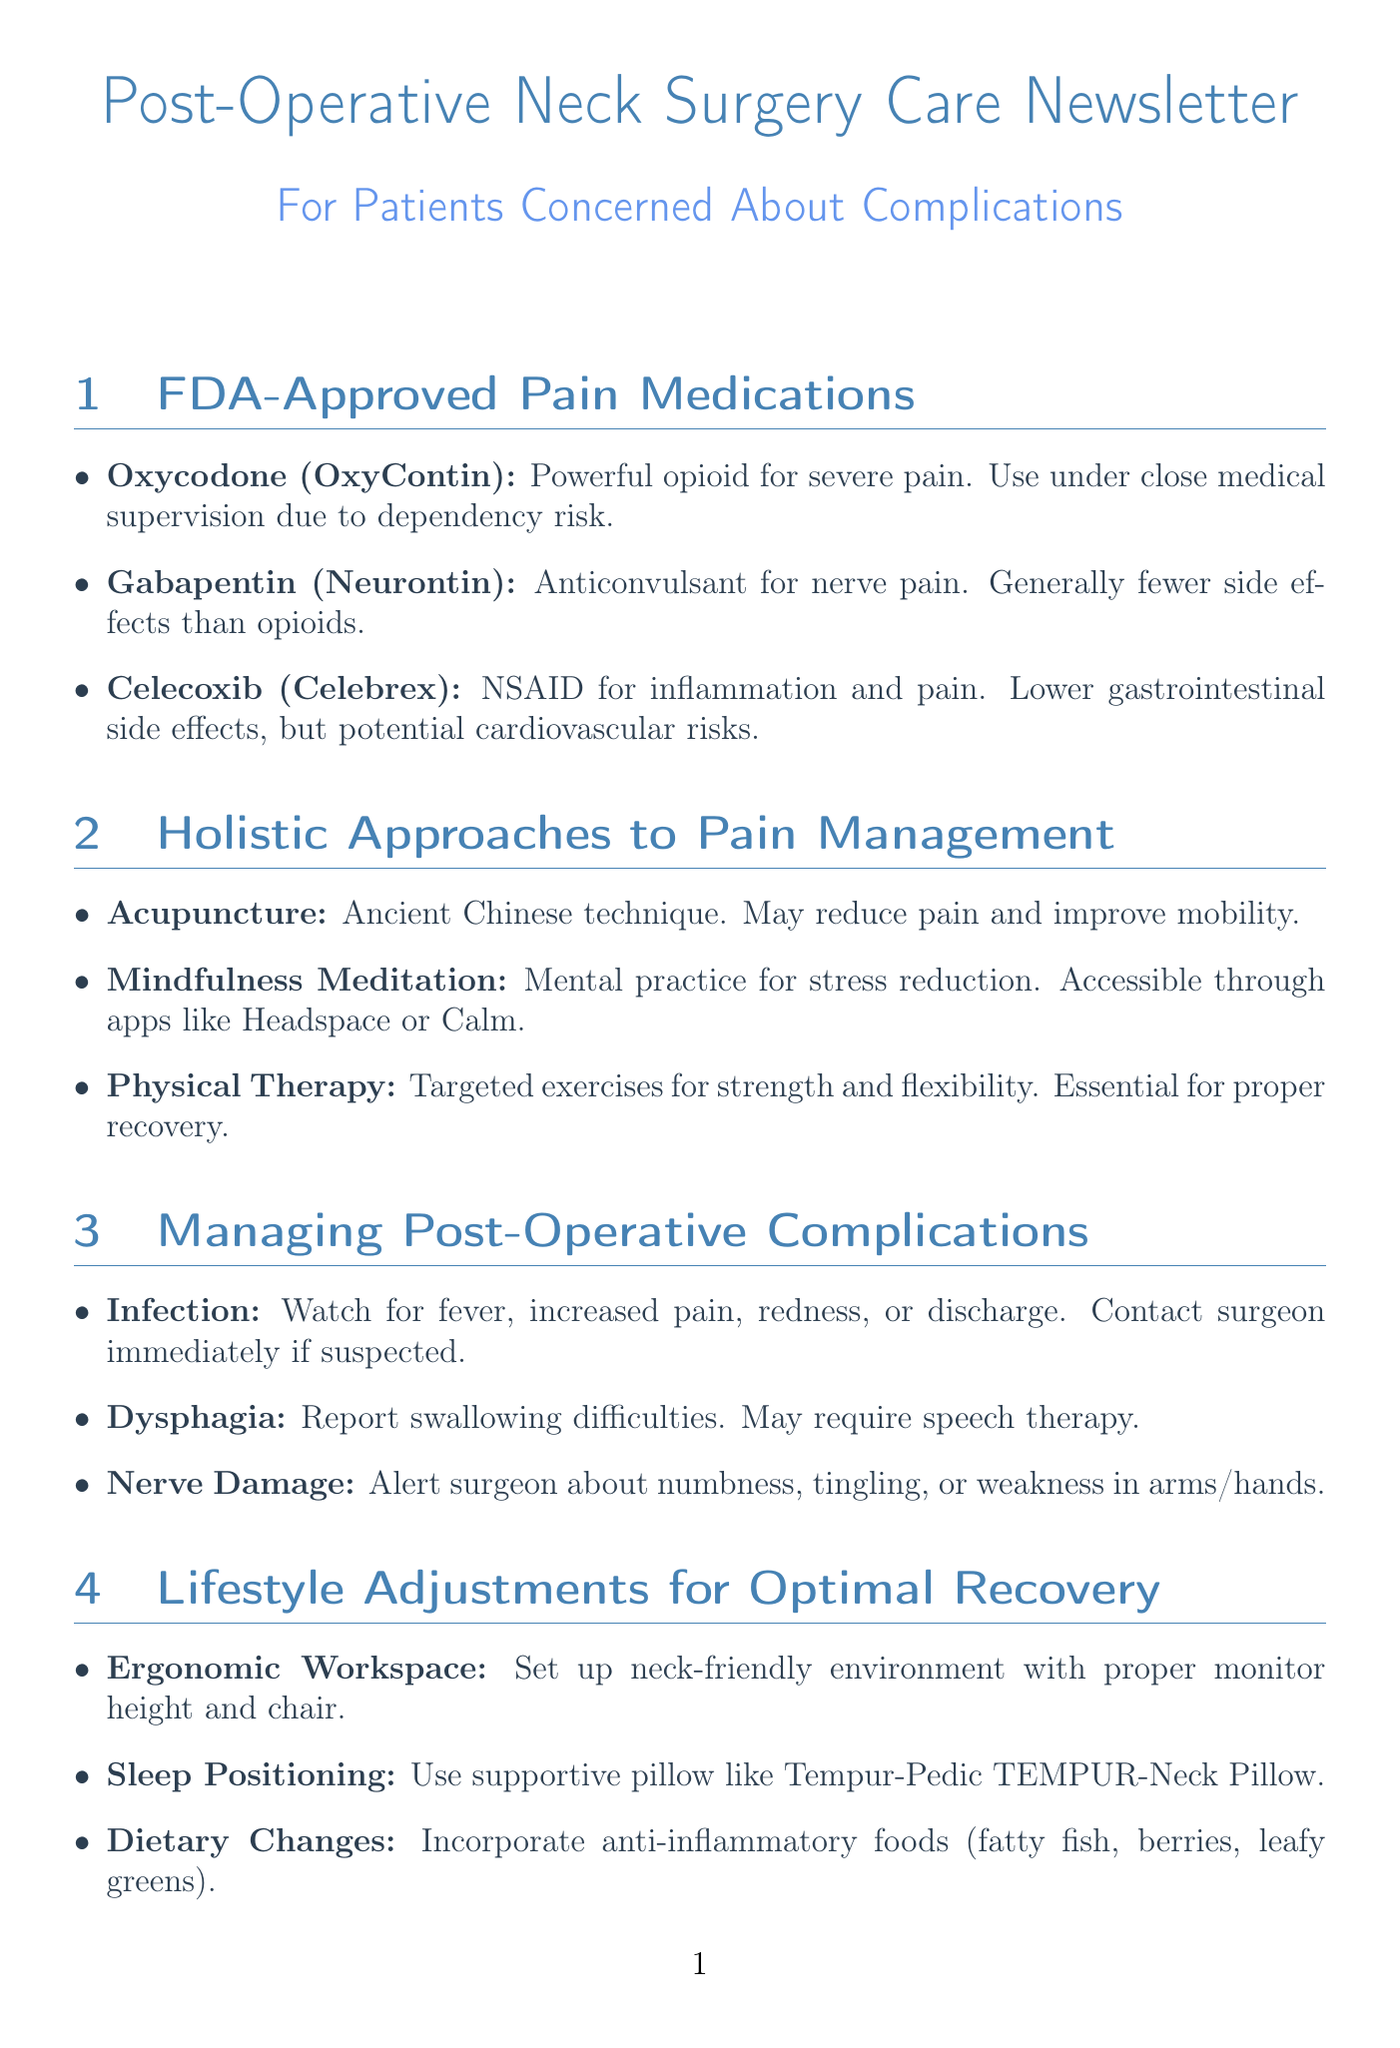What is the name of a powerful opioid for severe pain? The document lists Oxycodone (OxyContin) as a powerful opioid pain reliever often prescribed for severe post-operative pain.
Answer: Oxycodone (OxyContin) What type of drug is Gabapentin? Gabapentin is mentioned in the document as an anticonvulsant medication that is also used to treat nerve pain.
Answer: Anticonvulsant What is a potential risk of taking Celecoxib? Celecoxib is said to carry a potential risk of increasing cardiovascular risks in some patients.
Answer: Cardiovascular risks Which therapy uses thin needles for pain management? The document describes acupuncture as an ancient technique involving the insertion of thin needles.
Answer: Acupuncture What is one of the signs of infection post-surgery? The document states that fever is one of the signs to watch for in case of post-operative infection.
Answer: Fever What should you report if you experience difficulty swallowing? According to the document, you should report dysphagia if you have trouble swallowing after your neck surgery.
Answer: Dysphagia What is recommended for a neck-friendly work environment? The document suggests an ergonomic workspace setup with the proper monitor height and ergonomic chair.
Answer: Ergonomic workspace What is the benefit of using a supportive pillow? The document mentions that a supportive pillow promotes healing and reduces pain during sleep.
Answer: Promotes healing What organization offers education and support for chronic pain? The document lists the American Chronic Pain Association as a nonprofit organization offering education and support.
Answer: American Chronic Pain Association 